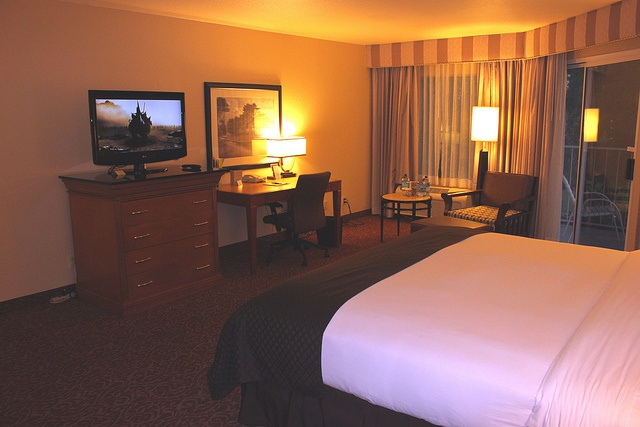Describe the objects in this image and their specific colors. I can see bed in brown, black, lightpink, pink, and salmon tones, tv in brown, black, and lavender tones, chair in brown, black, and maroon tones, chair in brown, black, and maroon tones, and chair in brown, gray, and black tones in this image. 